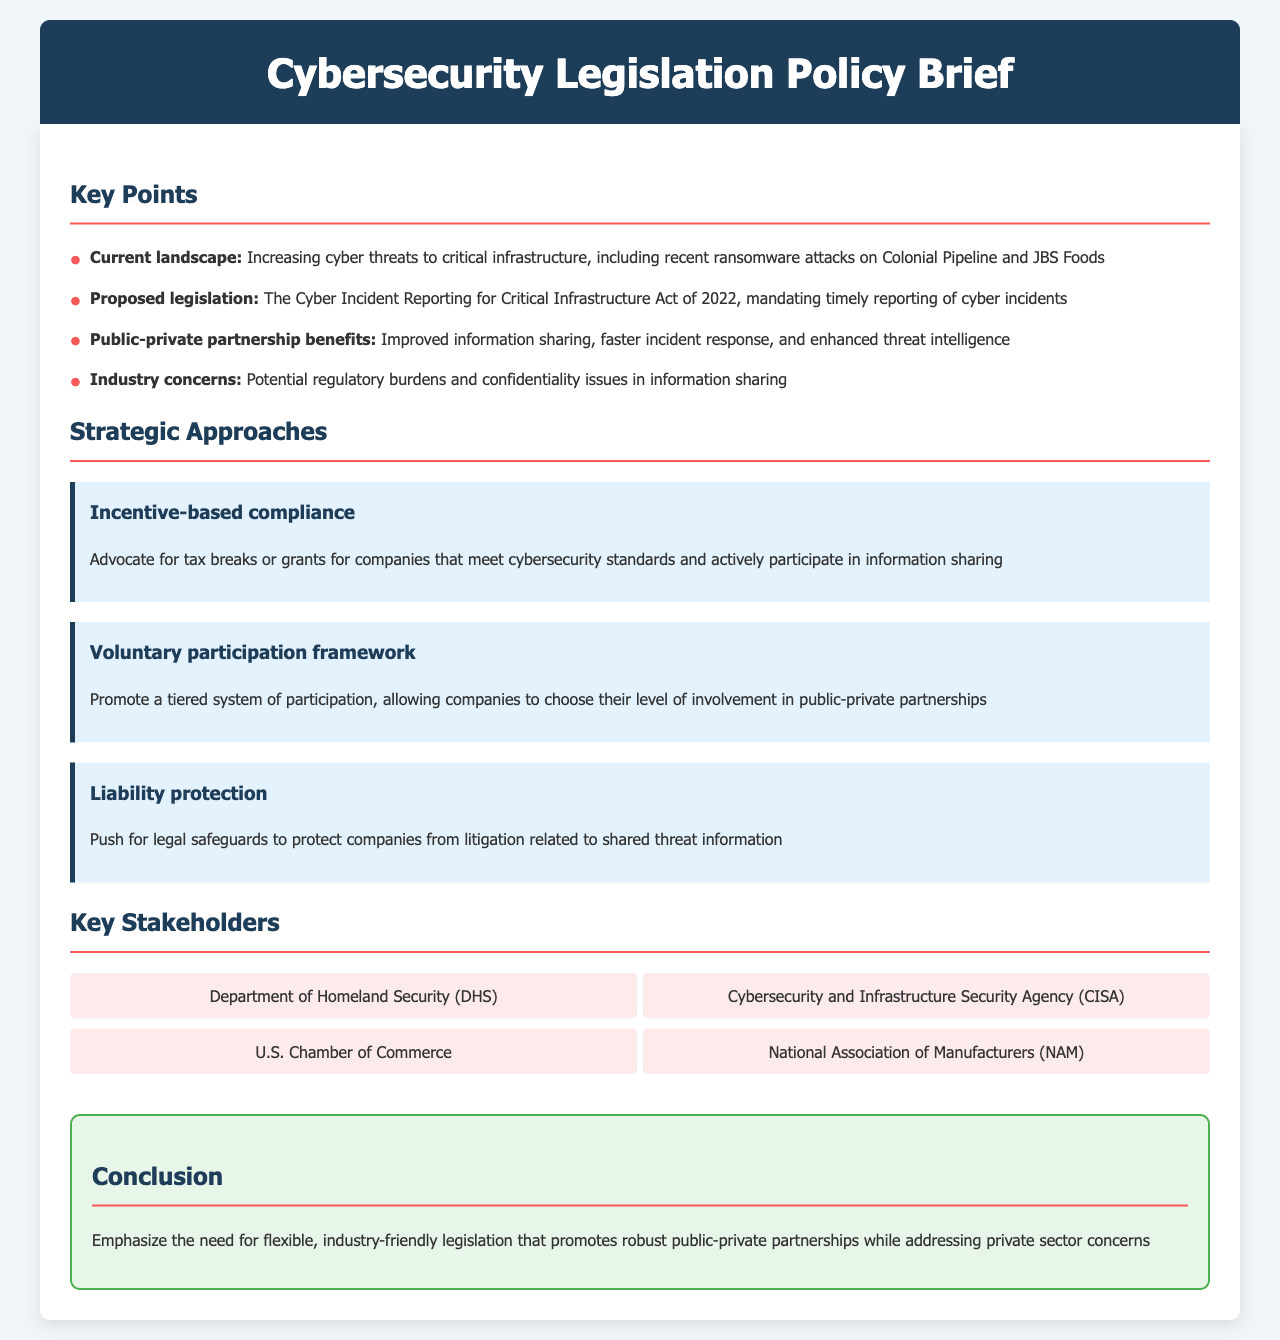What is the proposed legislation mentioned in the document? The proposed legislation is specifically mentioned in the context of cyber incident reporting, identified as "The Cyber Incident Reporting for Critical Infrastructure Act of 2022."
Answer: The Cyber Incident Reporting for Critical Infrastructure Act of 2022 What are two benefits of public-private partnerships outlined in the brief? The brief highlights improved information sharing and faster incident response as key benefits of public-private partnerships.
Answer: Improved information sharing, faster incident response Which agency is responsible for cybersecurity and infrastructure security? The agency identified in the document responsible for this is the Cybersecurity and Infrastructure Security Agency.
Answer: Cybersecurity and Infrastructure Security Agency (CISA) What is one industry concern related to cybersecurity legislation? The document notes potential regulatory burdens and confidentiality issues as concerns from the industry regarding the legislation.
Answer: Potential regulatory burdens How many strategic approaches are discussed in the document? The document outlines three distinct strategic approaches to addressing cybersecurity legislation.
Answer: Three What legal safeguard is proposed to protect companies sharing information? The document suggests that liability protection be implemented to safeguard companies from litigation arising from shared threat information.
Answer: Liability protection What is emphasized in the conclusion of the policy brief? The conclusion stresses the importance of legislation that is flexible and friendly to industry while addressing concerns of the private sector.
Answer: Flexible, industry-friendly legislation What type of compliance is advocated for in the strategic approaches? The document advocates for incentive-based compliance to encourage companies to meet cybersecurity standards.
Answer: Incentive-based compliance 